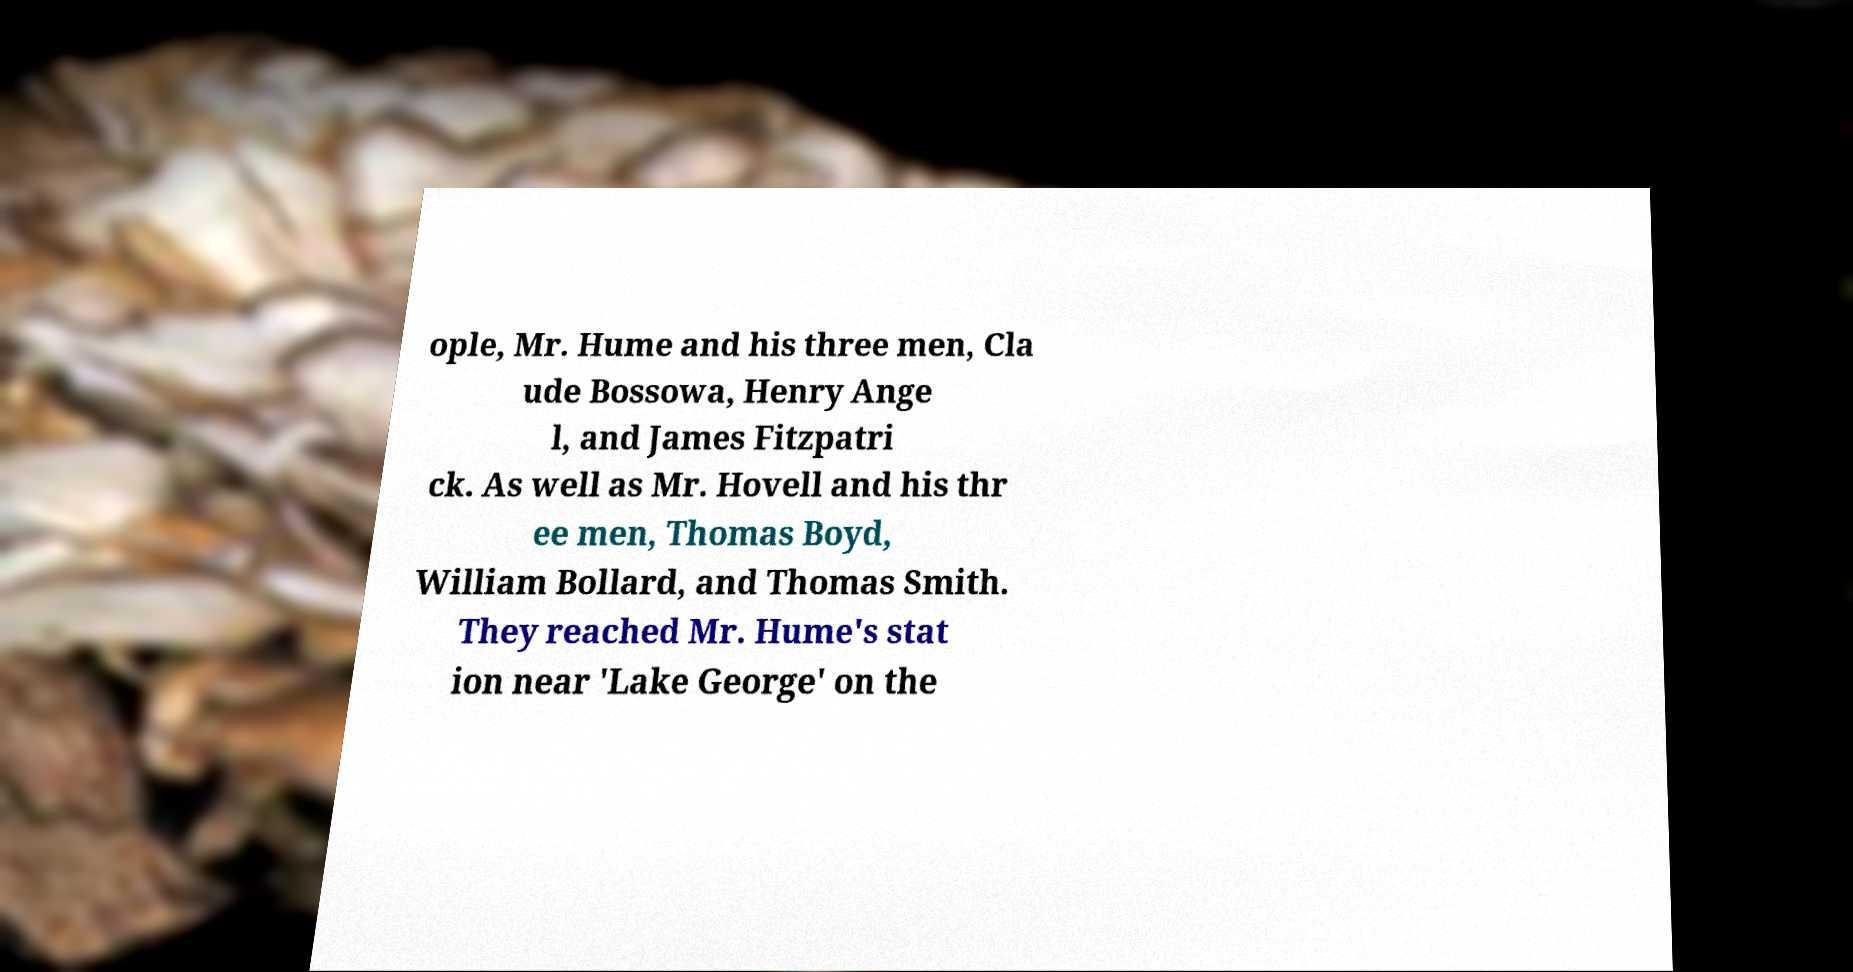There's text embedded in this image that I need extracted. Can you transcribe it verbatim? ople, Mr. Hume and his three men, Cla ude Bossowa, Henry Ange l, and James Fitzpatri ck. As well as Mr. Hovell and his thr ee men, Thomas Boyd, William Bollard, and Thomas Smith. They reached Mr. Hume's stat ion near 'Lake George' on the 